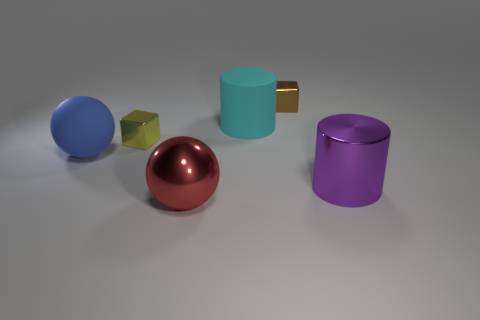Add 2 large purple cylinders. How many objects exist? 8 Subtract all cylinders. How many objects are left? 4 Subtract 0 brown spheres. How many objects are left? 6 Subtract all yellow shiny objects. Subtract all big purple cylinders. How many objects are left? 4 Add 1 tiny yellow cubes. How many tiny yellow cubes are left? 2 Add 4 tiny brown cylinders. How many tiny brown cylinders exist? 4 